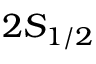<formula> <loc_0><loc_0><loc_500><loc_500>2 S _ { 1 / 2 }</formula> 